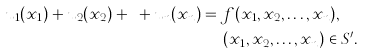<formula> <loc_0><loc_0><loc_500><loc_500>u _ { 1 } ( x _ { 1 } ) + u _ { 2 } ( x _ { 2 } ) + \cdots + u _ { n } ( x _ { n } ) & = f ( x _ { 1 } , x _ { 2 } , \dots , x _ { n } ) , \\ & \quad \ ( x _ { 1 } , x _ { 2 } , \dots , x _ { n } ) \in S ^ { \prime } .</formula> 